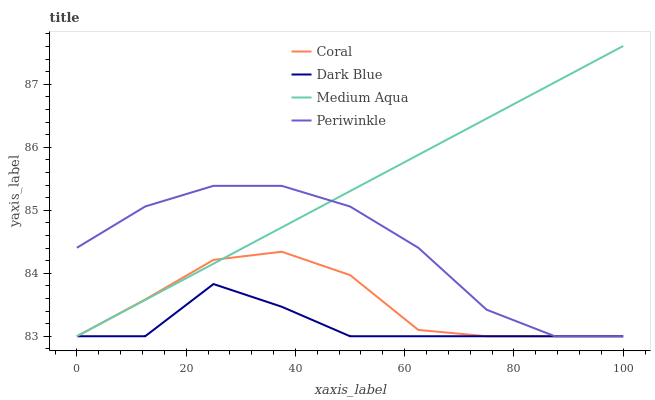Does Dark Blue have the minimum area under the curve?
Answer yes or no. Yes. Does Medium Aqua have the maximum area under the curve?
Answer yes or no. Yes. Does Coral have the minimum area under the curve?
Answer yes or no. No. Does Coral have the maximum area under the curve?
Answer yes or no. No. Is Medium Aqua the smoothest?
Answer yes or no. Yes. Is Periwinkle the roughest?
Answer yes or no. Yes. Is Dark Blue the smoothest?
Answer yes or no. No. Is Dark Blue the roughest?
Answer yes or no. No. Does Periwinkle have the lowest value?
Answer yes or no. Yes. Does Medium Aqua have the highest value?
Answer yes or no. Yes. Does Coral have the highest value?
Answer yes or no. No. Does Medium Aqua intersect Coral?
Answer yes or no. Yes. Is Medium Aqua less than Coral?
Answer yes or no. No. Is Medium Aqua greater than Coral?
Answer yes or no. No. 